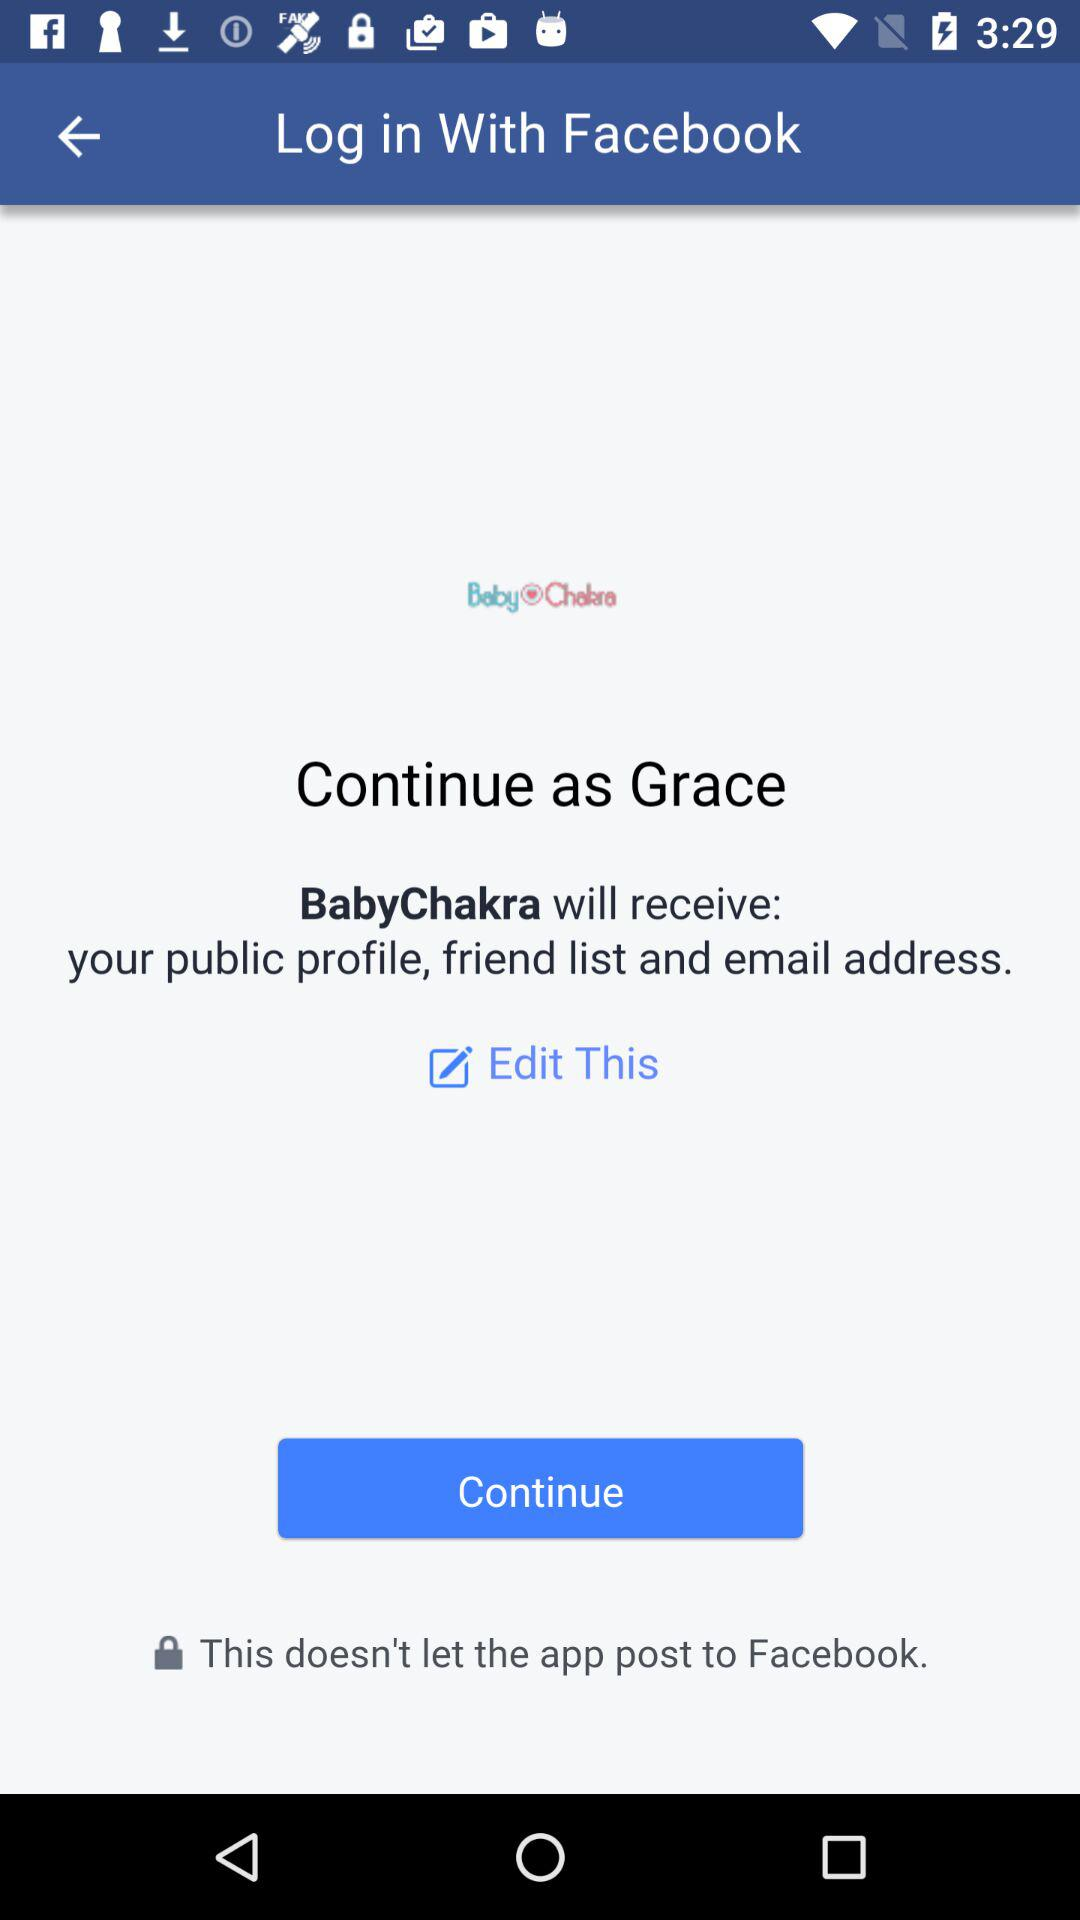What application is asking for permission? The application asking for permission is "BabyChakra". 